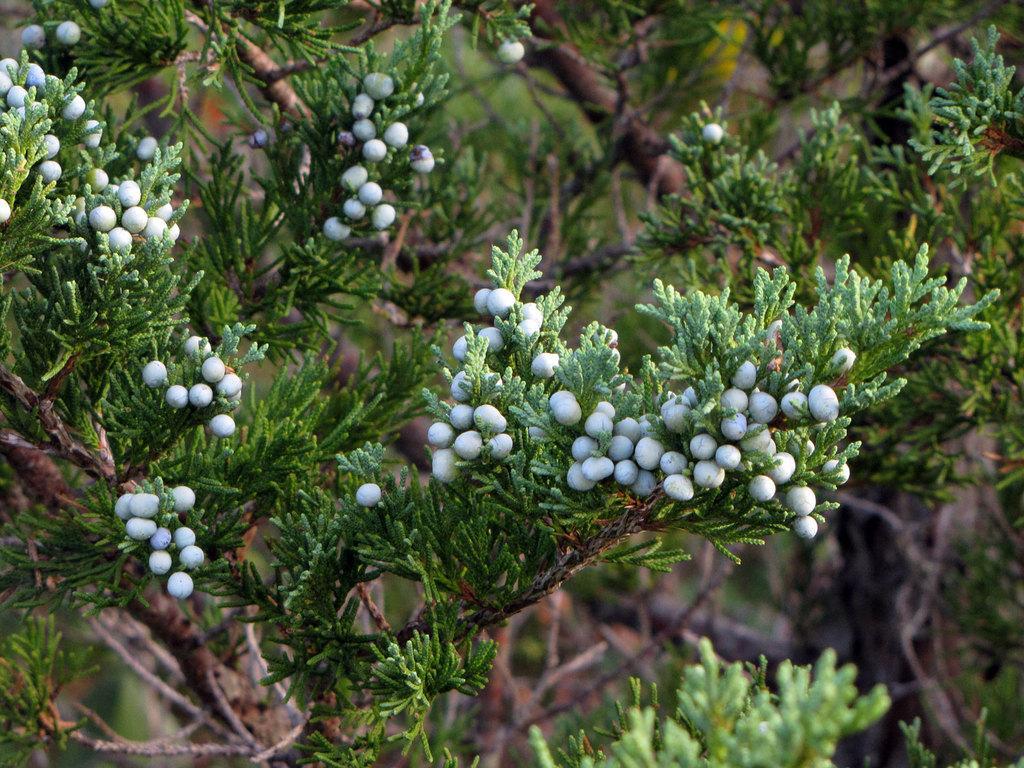Can you describe this image briefly? In this image there are so many white colour birds to the tree and there are green leaves around it. 